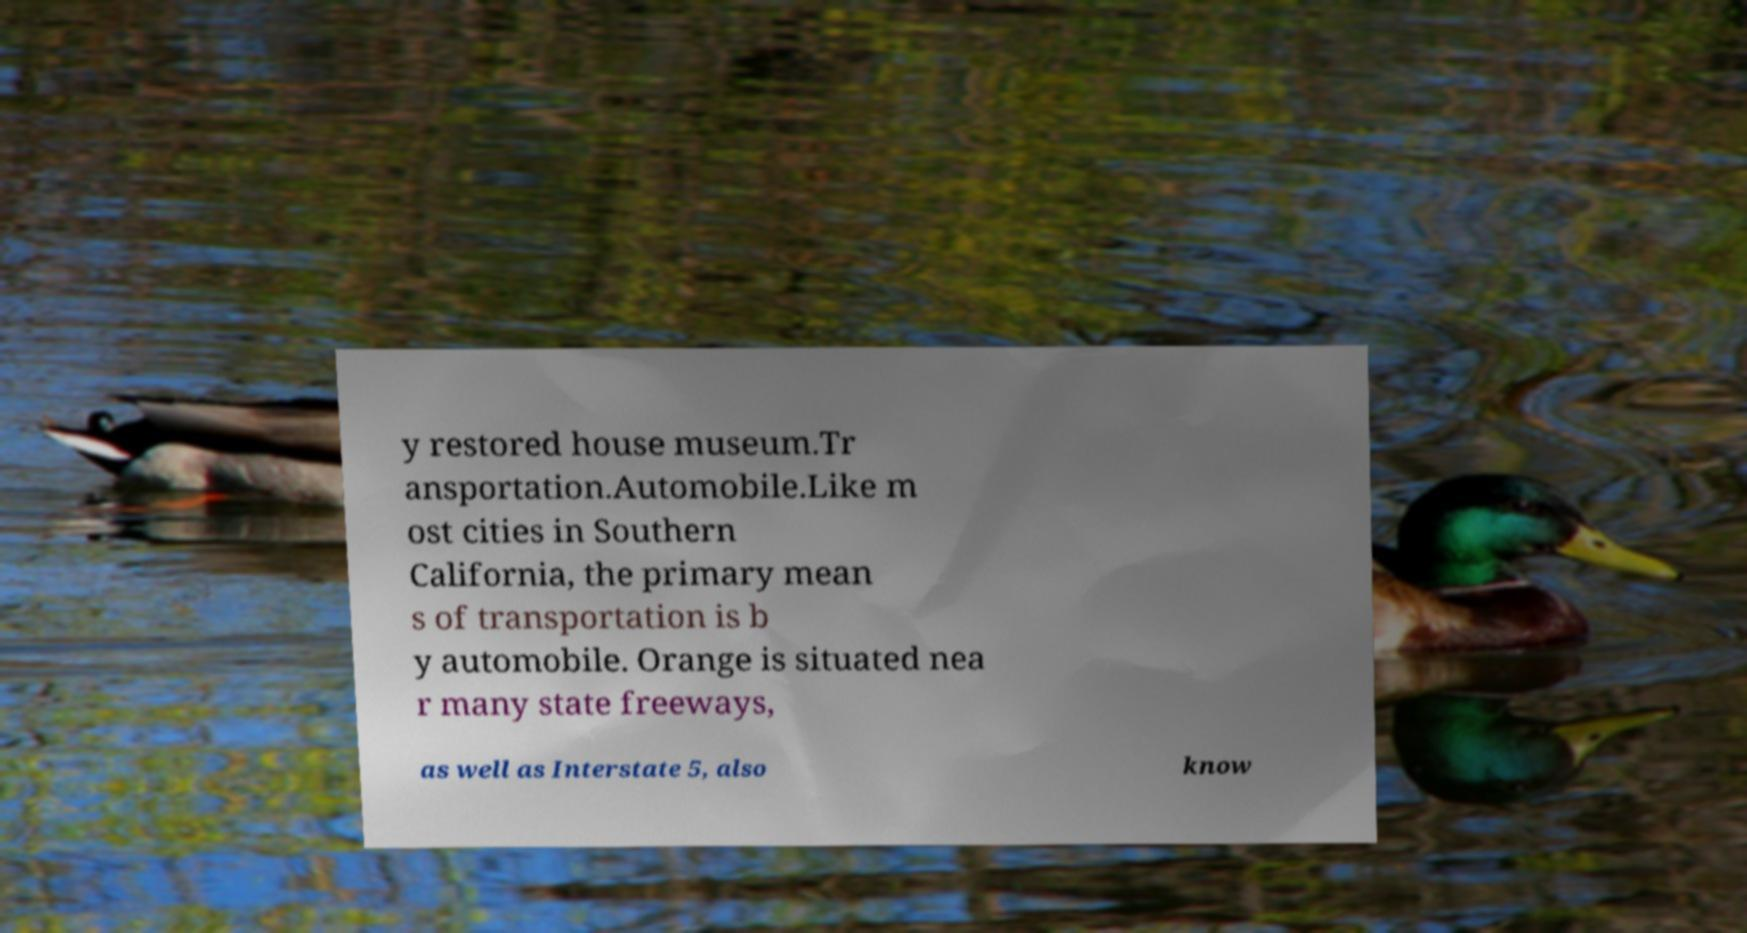Could you extract and type out the text from this image? y restored house museum.Tr ansportation.Automobile.Like m ost cities in Southern California, the primary mean s of transportation is b y automobile. Orange is situated nea r many state freeways, as well as Interstate 5, also know 